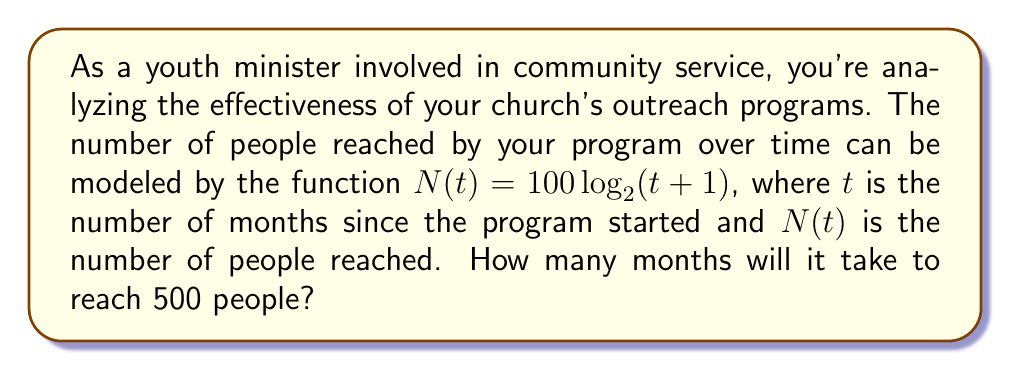Can you solve this math problem? To solve this problem, we need to use the given logarithmic function and solve for $t$ when $N(t) = 500$. Let's break it down step-by-step:

1) We start with the equation:
   $N(t) = 100 \log_2(t+1)$

2) We want to find $t$ when $N(t) = 500$, so we set up the equation:
   $500 = 100 \log_2(t+1)$

3) Divide both sides by 100:
   $5 = \log_2(t+1)$

4) To solve for $t$, we need to apply the inverse function of $\log_2$, which is $2^x$:
   $2^5 = t+1$

5) Calculate $2^5$:
   $32 = t+1$

6) Subtract 1 from both sides:
   $31 = t$

Therefore, it will take 31 months to reach 500 people.

To verify:
$N(31) = 100 \log_2(31+1) = 100 \log_2(32) = 100 * 5 = 500$
Answer: 31 months 